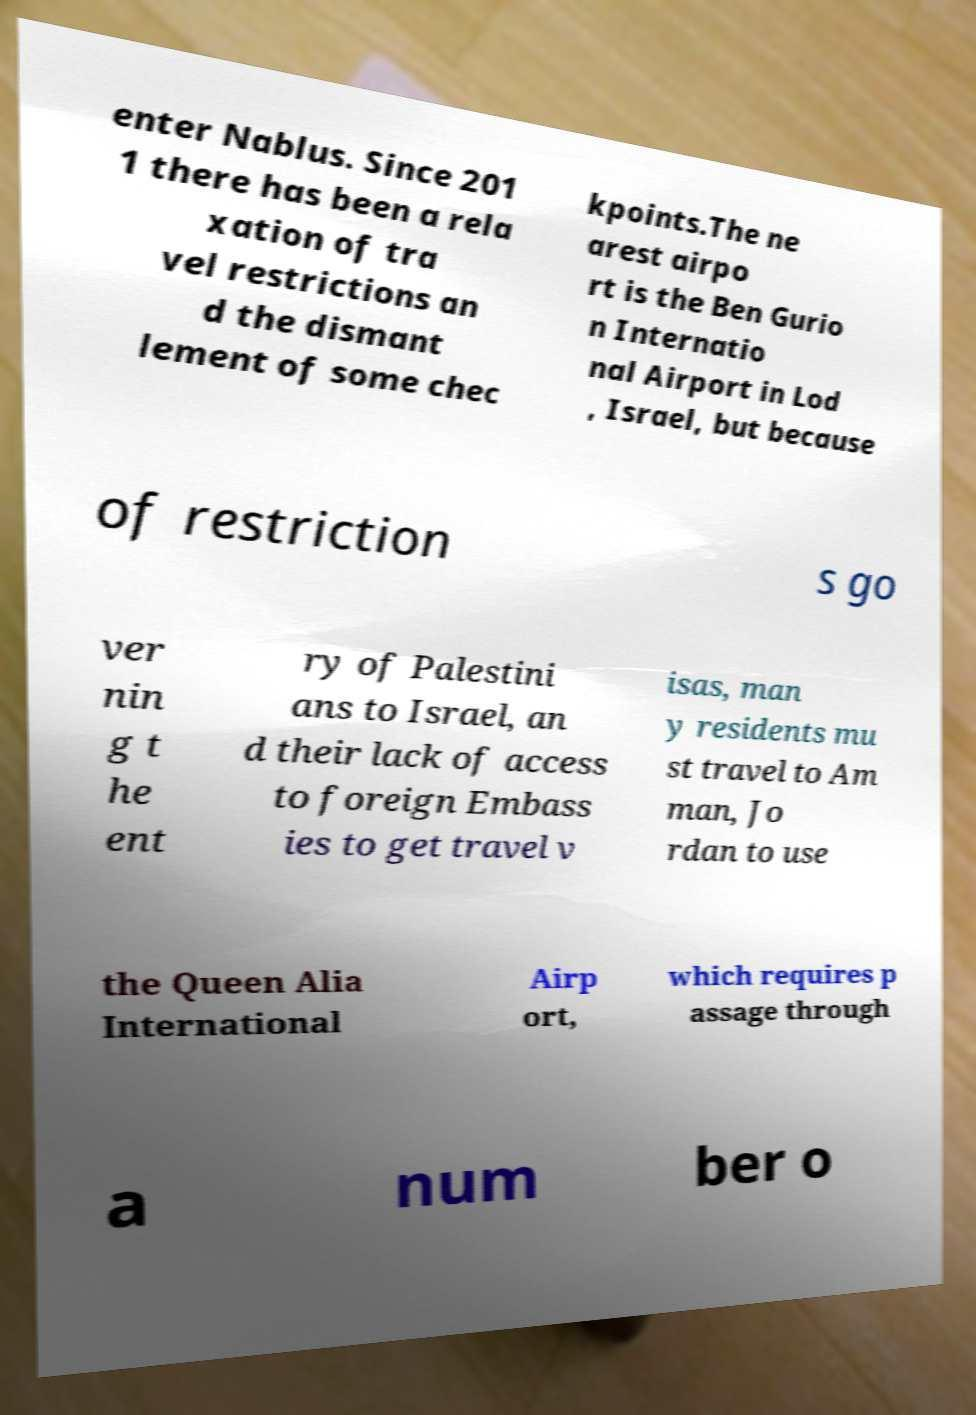Please read and relay the text visible in this image. What does it say? enter Nablus. Since 201 1 there has been a rela xation of tra vel restrictions an d the dismant lement of some chec kpoints.The ne arest airpo rt is the Ben Gurio n Internatio nal Airport in Lod , Israel, but because of restriction s go ver nin g t he ent ry of Palestini ans to Israel, an d their lack of access to foreign Embass ies to get travel v isas, man y residents mu st travel to Am man, Jo rdan to use the Queen Alia International Airp ort, which requires p assage through a num ber o 